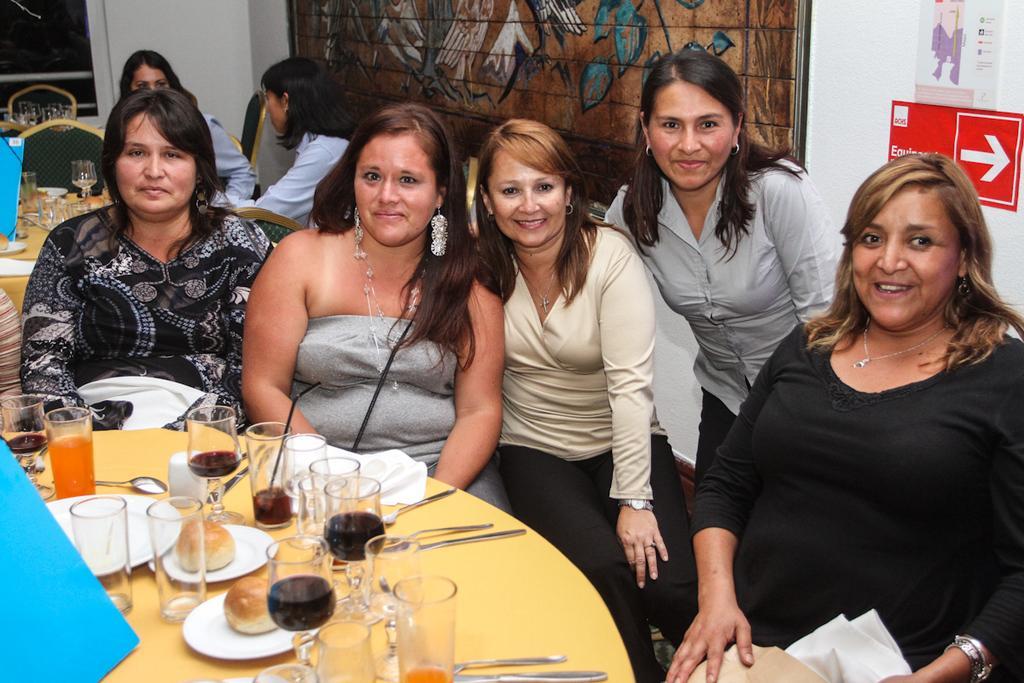Could you give a brief overview of what you see in this image? In the image we can see there are women who are sitting on chair and in front of them there is a table on which there are wine glass, spoon, plates, bun and fork. 